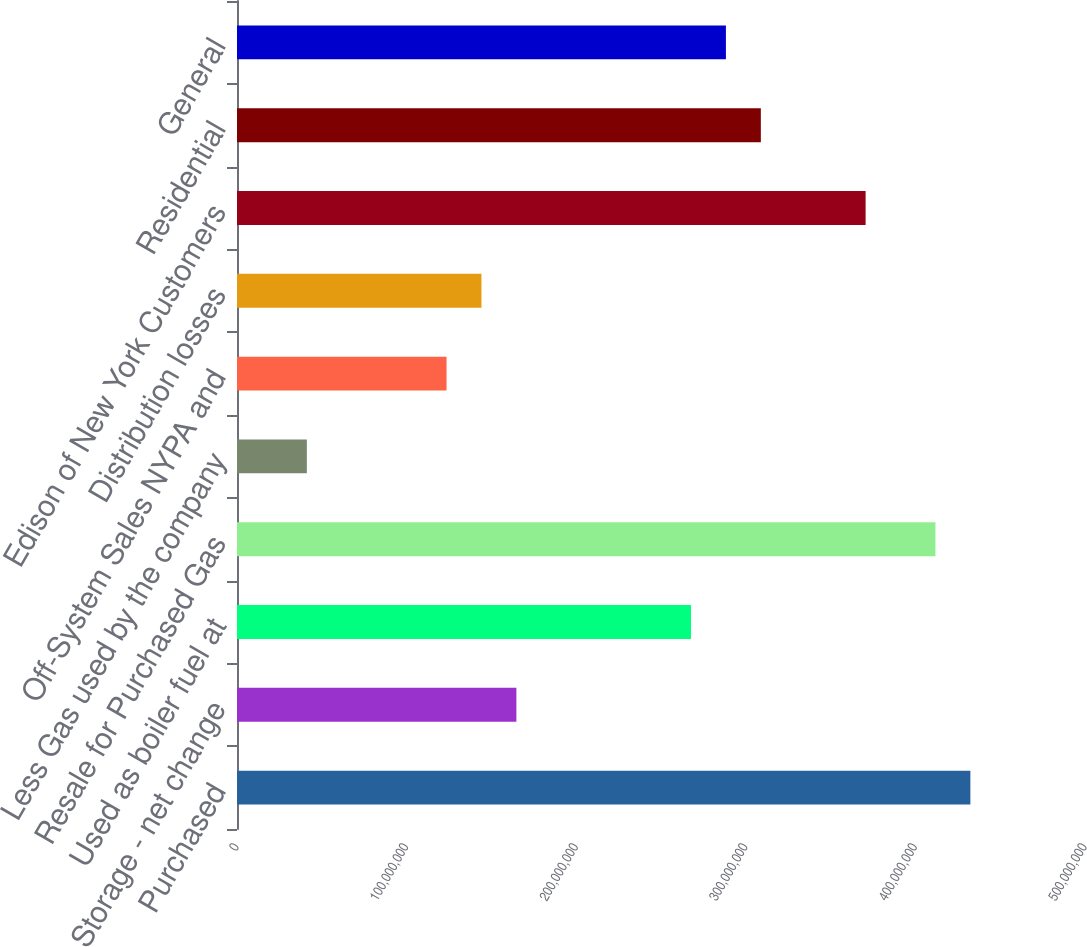<chart> <loc_0><loc_0><loc_500><loc_500><bar_chart><fcel>Purchased<fcel>Storage - net change<fcel>Used as boiler fuel at<fcel>Resale for Purchased Gas<fcel>Less Gas used by the company<fcel>Off-System Sales NYPA and<fcel>Distribution losses<fcel>Edison of New York Customers<fcel>Residential<fcel>General<nl><fcel>4.32415e+08<fcel>1.64729e+08<fcel>2.67685e+08<fcel>4.11823e+08<fcel>4.11824e+07<fcel>1.23547e+08<fcel>1.44138e+08<fcel>3.70641e+08<fcel>3.08868e+08<fcel>2.88276e+08<nl></chart> 